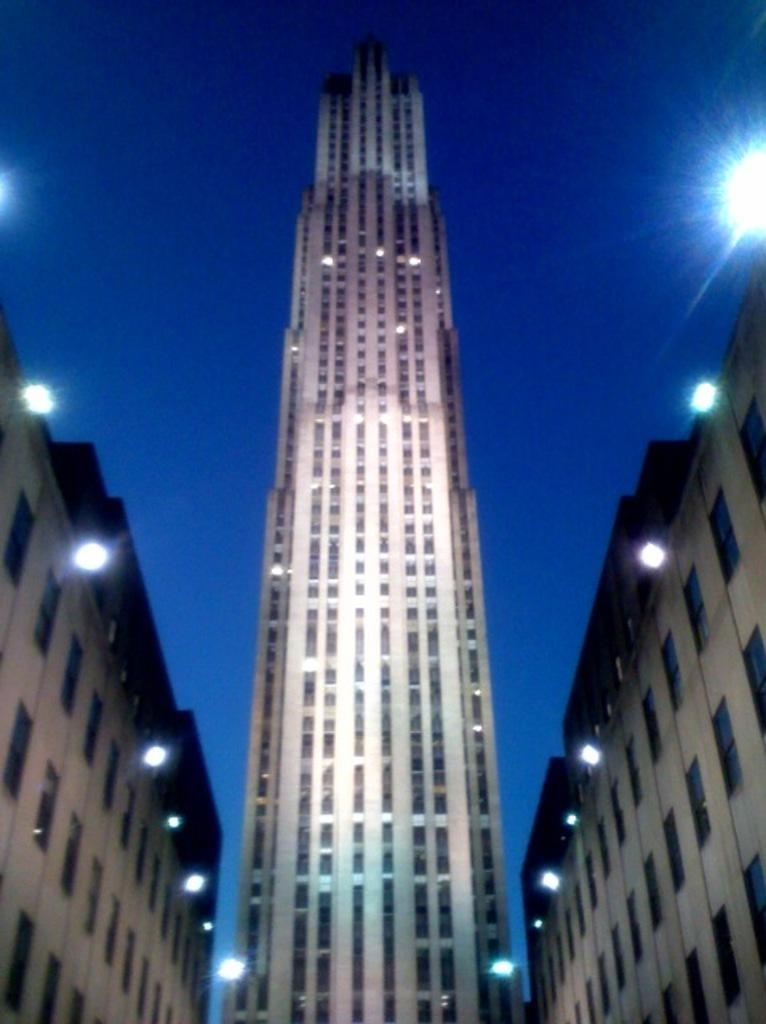What type of structures are located in the center of the image? There are buildings and skyscrapers in the center of the image. What can be seen in the background of the image? There is sky visible in the background of the image. Are there any additional features present in the background? Yes, there are lights present in the background of the image. How many girls are sitting on the sheet in the image? There are no girls or sheets present in the image. 